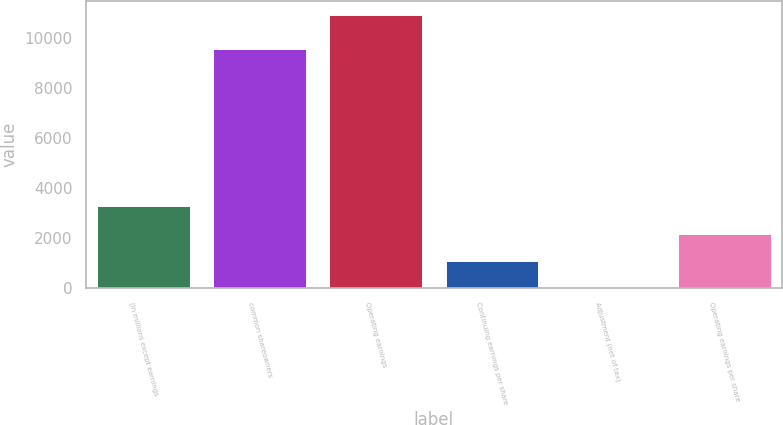<chart> <loc_0><loc_0><loc_500><loc_500><bar_chart><fcel>(In millions except earnings<fcel>common shareowners<fcel>Operating earnings<fcel>Continuing earnings per share<fcel>Adjustment (net of tax)<fcel>Operating earnings per share<nl><fcel>3274.01<fcel>9535<fcel>10913<fcel>1091.43<fcel>0.14<fcel>2182.72<nl></chart> 